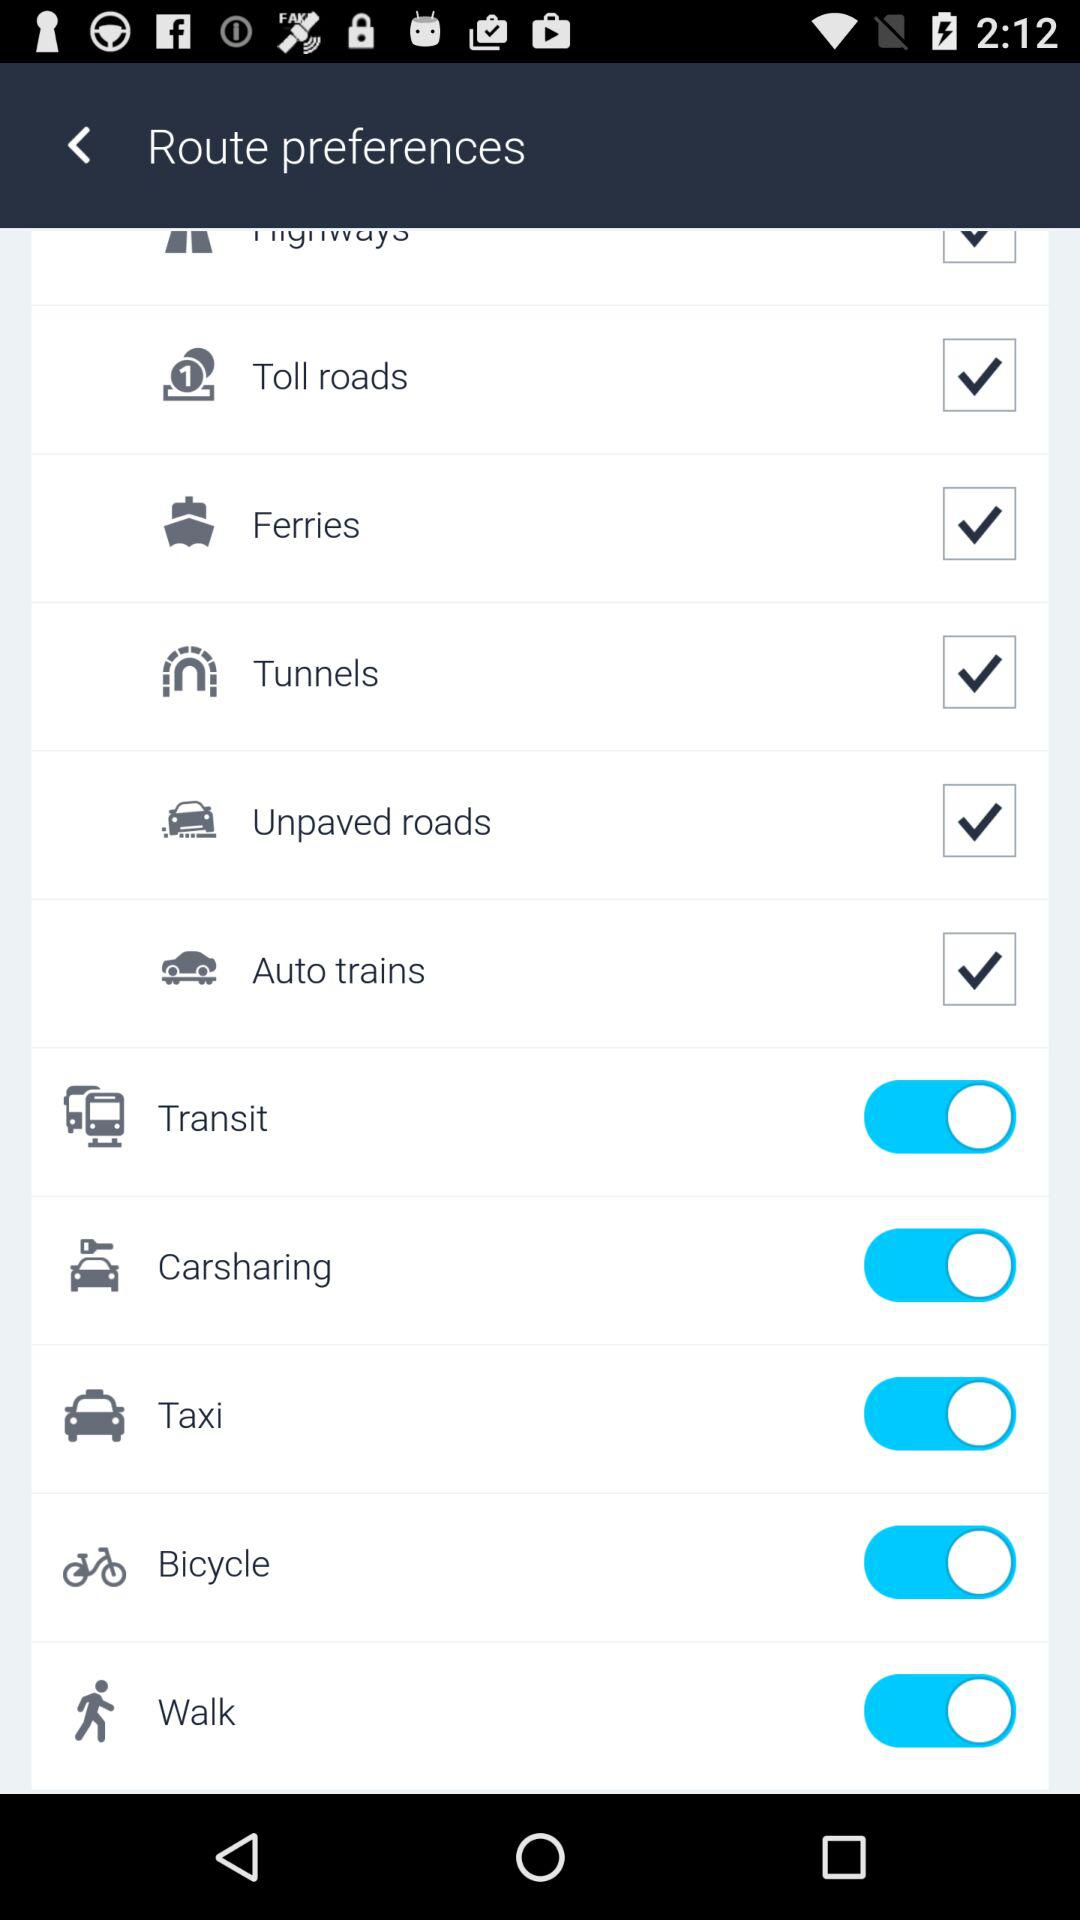What options are on under "Route preferences"? The options are: "Transit", "Carsharing", "Taxi", "Bicycle", and "Walk". 